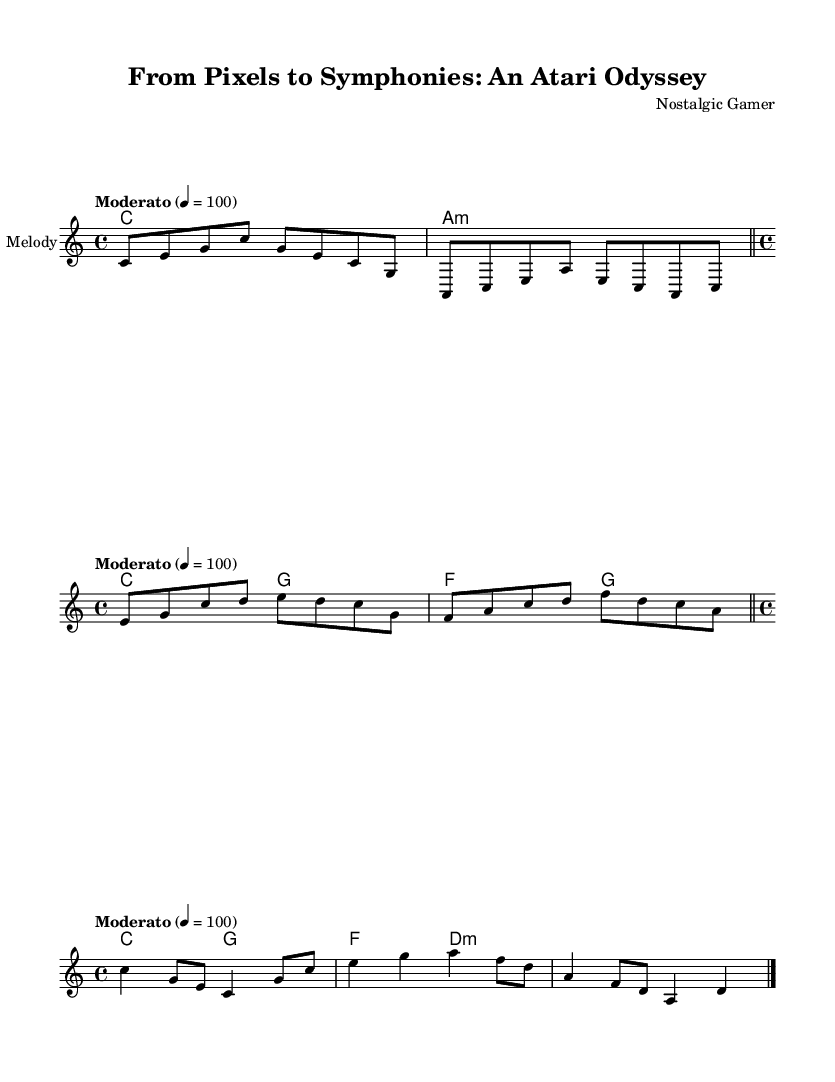What is the key signature of this music? The key signature is C major, which has no sharps or flats.
Answer: C major What is the time signature of the piece? The time signature is indicated at the beginning and shows that each measure contains four beats, with each beat as a quarter note.
Answer: 4/4 What is the tempo marking for this symphony? The tempo marking is written above the staff and specifies the speed at which the piece should be played, indicated by a metronome marking of 100 beats per minute.
Answer: Moderato 4 = 100 How many different sections are present in this symphony? There are three distinct sections: the eight-bit overture, the sixteen-bit interlude, and the orchestral finale, which reflect the evolution of video game music.
Answer: Three What type of chords accompany the eight-bit overture? The chords are simple and characteristic of the eight-bit sound, where each chord consists of basic triads and can evoke a nostalgic atmosphere.
Answer: C major and A minor Which section of the composition is the most complex in terms of harmony? The orchestral finale features more intricate harmonic progressions and dynamics, contrasting with the simpler, more repetitive sections of the earlier parts.
Answer: Orchestral finale 